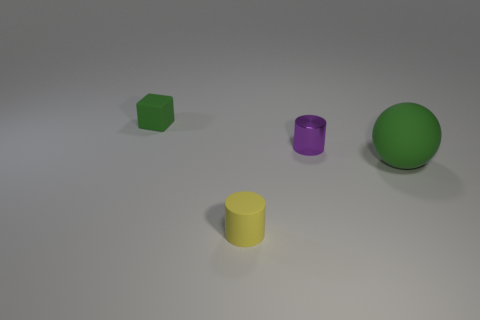Is there anything else that has the same size as the rubber ball?
Provide a succinct answer. No. Are there any gray shiny cylinders of the same size as the green rubber cube?
Give a very brief answer. No. Is the number of tiny blocks on the right side of the small matte cylinder less than the number of small gray cylinders?
Offer a terse response. No. Are there fewer small yellow rubber things that are on the left side of the small yellow thing than purple objects behind the small green cube?
Offer a terse response. No. How many cylinders are purple objects or brown rubber objects?
Provide a succinct answer. 1. Does the tiny cylinder behind the large green object have the same material as the green sphere on the right side of the small cube?
Your answer should be compact. No. The purple metallic object that is the same size as the yellow object is what shape?
Your response must be concise. Cylinder. What number of other things are the same color as the tiny metal cylinder?
Give a very brief answer. 0. What number of yellow things are either large rubber things or metal things?
Make the answer very short. 0. There is a small metal object that is on the left side of the large green rubber thing; does it have the same shape as the tiny object on the left side of the yellow rubber object?
Your response must be concise. No. 